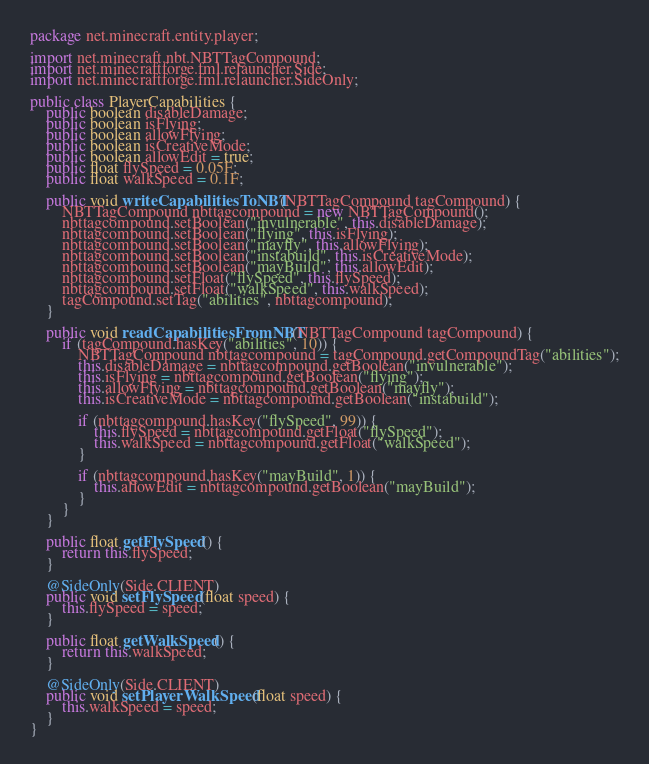<code> <loc_0><loc_0><loc_500><loc_500><_Java_>package net.minecraft.entity.player;

import net.minecraft.nbt.NBTTagCompound;
import net.minecraftforge.fml.relauncher.Side;
import net.minecraftforge.fml.relauncher.SideOnly;

public class PlayerCapabilities {
    public boolean disableDamage;
    public boolean isFlying;
    public boolean allowFlying;
    public boolean isCreativeMode;
    public boolean allowEdit = true;
    public float flySpeed = 0.05F;
    public float walkSpeed = 0.1F;

    public void writeCapabilitiesToNBT(NBTTagCompound tagCompound) {
        NBTTagCompound nbttagcompound = new NBTTagCompound();
        nbttagcompound.setBoolean("invulnerable", this.disableDamage);
        nbttagcompound.setBoolean("flying", this.isFlying);
        nbttagcompound.setBoolean("mayfly", this.allowFlying);
        nbttagcompound.setBoolean("instabuild", this.isCreativeMode);
        nbttagcompound.setBoolean("mayBuild", this.allowEdit);
        nbttagcompound.setFloat("flySpeed", this.flySpeed);
        nbttagcompound.setFloat("walkSpeed", this.walkSpeed);
        tagCompound.setTag("abilities", nbttagcompound);
    }

    public void readCapabilitiesFromNBT(NBTTagCompound tagCompound) {
        if (tagCompound.hasKey("abilities", 10)) {
            NBTTagCompound nbttagcompound = tagCompound.getCompoundTag("abilities");
            this.disableDamage = nbttagcompound.getBoolean("invulnerable");
            this.isFlying = nbttagcompound.getBoolean("flying");
            this.allowFlying = nbttagcompound.getBoolean("mayfly");
            this.isCreativeMode = nbttagcompound.getBoolean("instabuild");

            if (nbttagcompound.hasKey("flySpeed", 99)) {
                this.flySpeed = nbttagcompound.getFloat("flySpeed");
                this.walkSpeed = nbttagcompound.getFloat("walkSpeed");
            }

            if (nbttagcompound.hasKey("mayBuild", 1)) {
                this.allowEdit = nbttagcompound.getBoolean("mayBuild");
            }
        }
    }

    public float getFlySpeed() {
        return this.flySpeed;
    }

    @SideOnly(Side.CLIENT)
    public void setFlySpeed(float speed) {
        this.flySpeed = speed;
    }

    public float getWalkSpeed() {
        return this.walkSpeed;
    }

    @SideOnly(Side.CLIENT)
    public void setPlayerWalkSpeed(float speed) {
        this.walkSpeed = speed;
    }
}</code> 